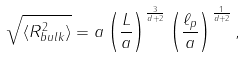Convert formula to latex. <formula><loc_0><loc_0><loc_500><loc_500>\sqrt { \langle R _ { b u l k } ^ { 2 } \rangle } = a \left ( \frac { L } { a } \right ) ^ { \frac { 3 } { d + 2 } } \left ( \frac { \ell _ { p } } { a } \right ) ^ { \frac { 1 } { d + 2 } } ,</formula> 